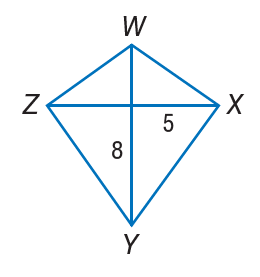Answer the mathemtical geometry problem and directly provide the correct option letter.
Question: If W X Y Z is a kite, find Y Z.
Choices: A: 5 B: 8 C: \sqrt { 89 } D: 25 C 